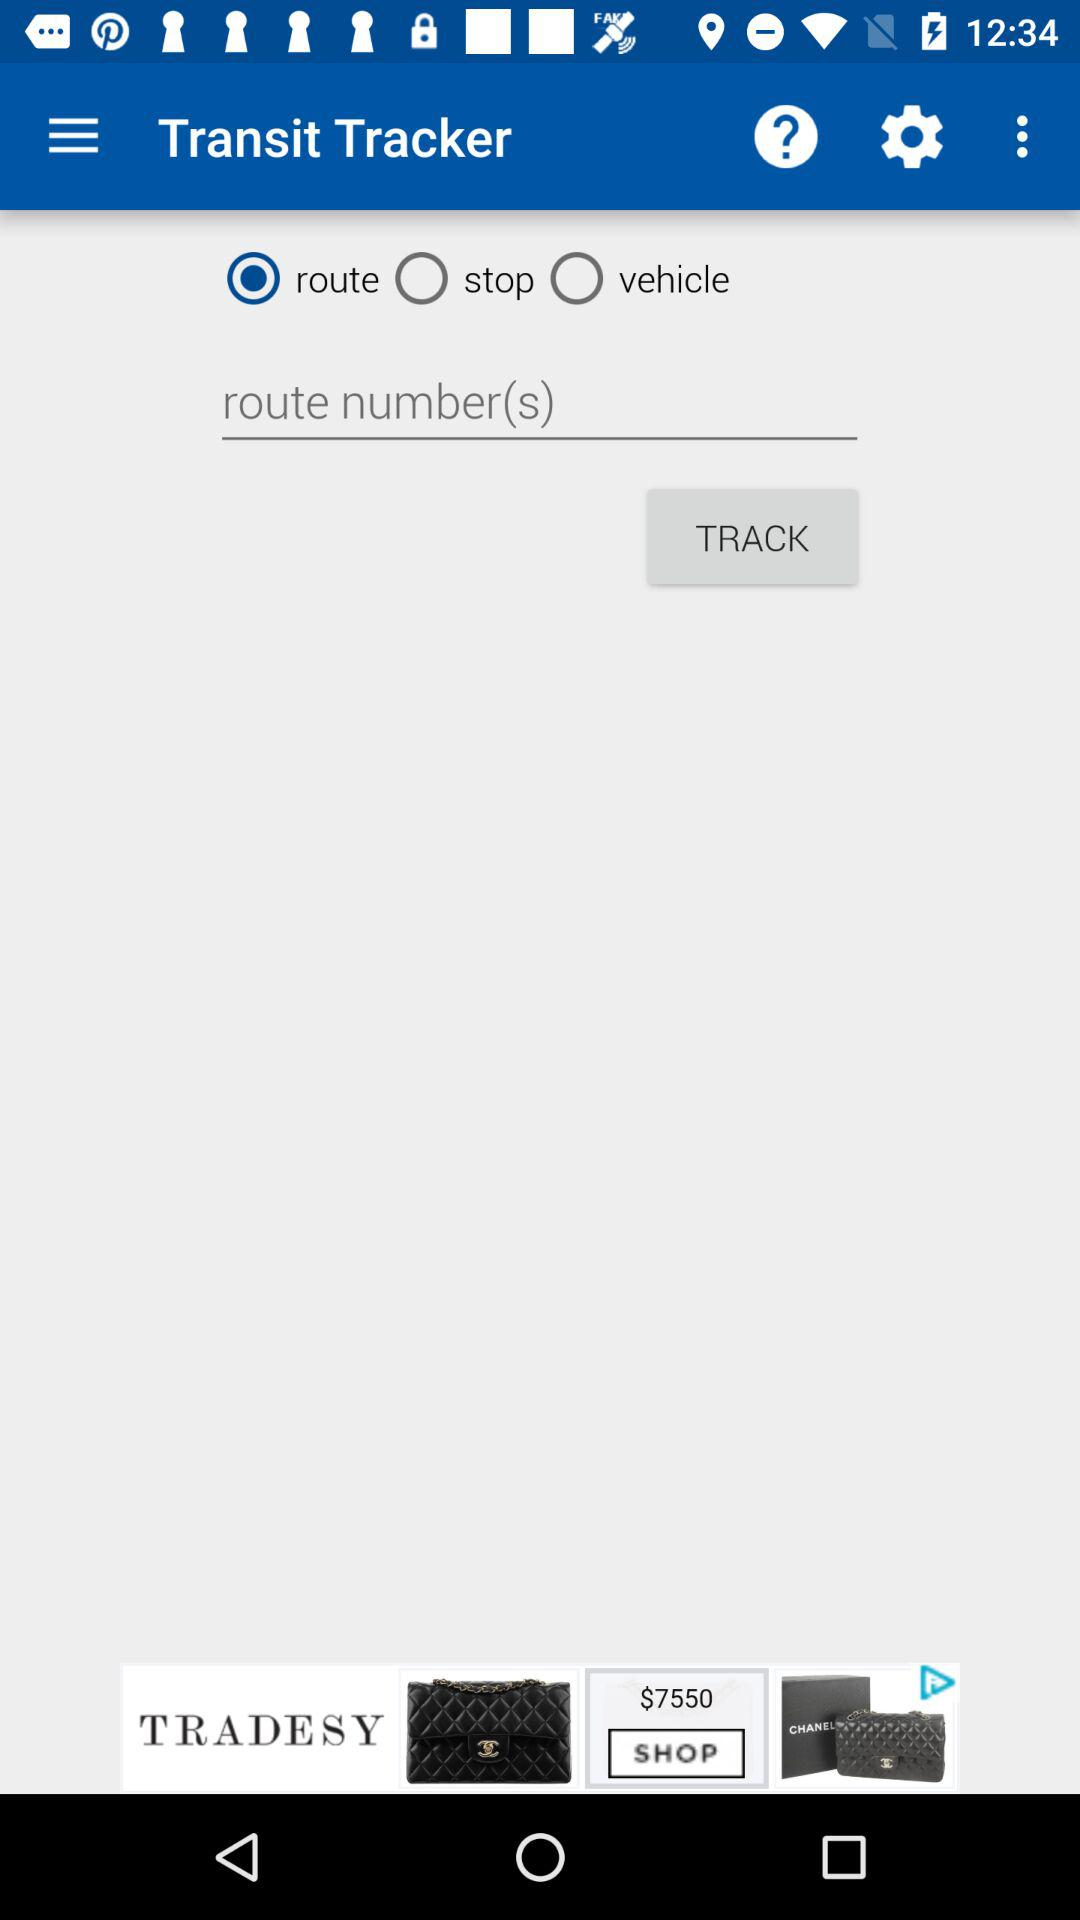Which option is selected? The selected option is "route". 